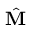<formula> <loc_0><loc_0><loc_500><loc_500>\hat { M }</formula> 